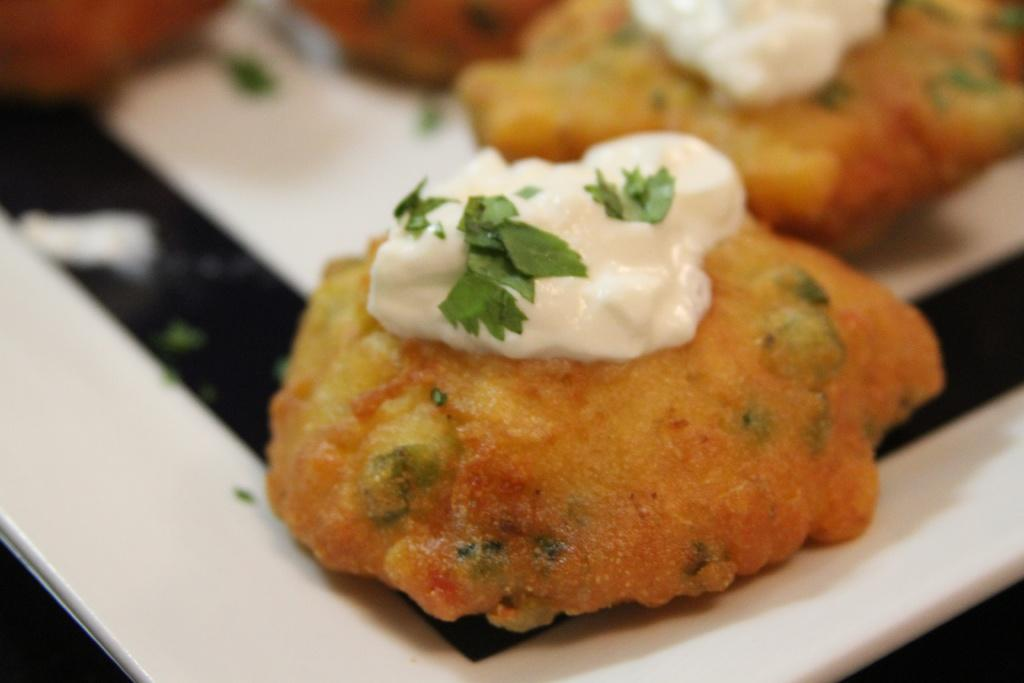What is the main subject of the image? There is a food item on a plate in the image. What team is responsible for cooking the rice in the image? There is no rice present in the image, and therefore no team responsible for cooking it. 